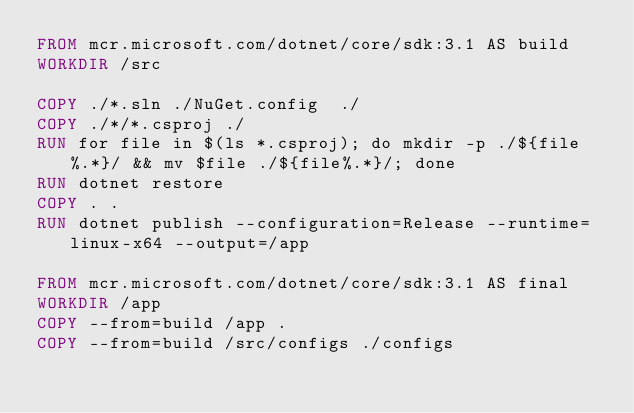<code> <loc_0><loc_0><loc_500><loc_500><_Dockerfile_>FROM mcr.microsoft.com/dotnet/core/sdk:3.1 AS build 
WORKDIR /src

COPY ./*.sln ./NuGet.config  ./
COPY ./*/*.csproj ./
RUN for file in $(ls *.csproj); do mkdir -p ./${file%.*}/ && mv $file ./${file%.*}/; done
RUN dotnet restore
COPY . .
RUN dotnet publish --configuration=Release --runtime=linux-x64 --output=/app  

FROM mcr.microsoft.com/dotnet/core/sdk:3.1 AS final  
WORKDIR /app
COPY --from=build /app .
COPY --from=build /src/configs ./configs</code> 